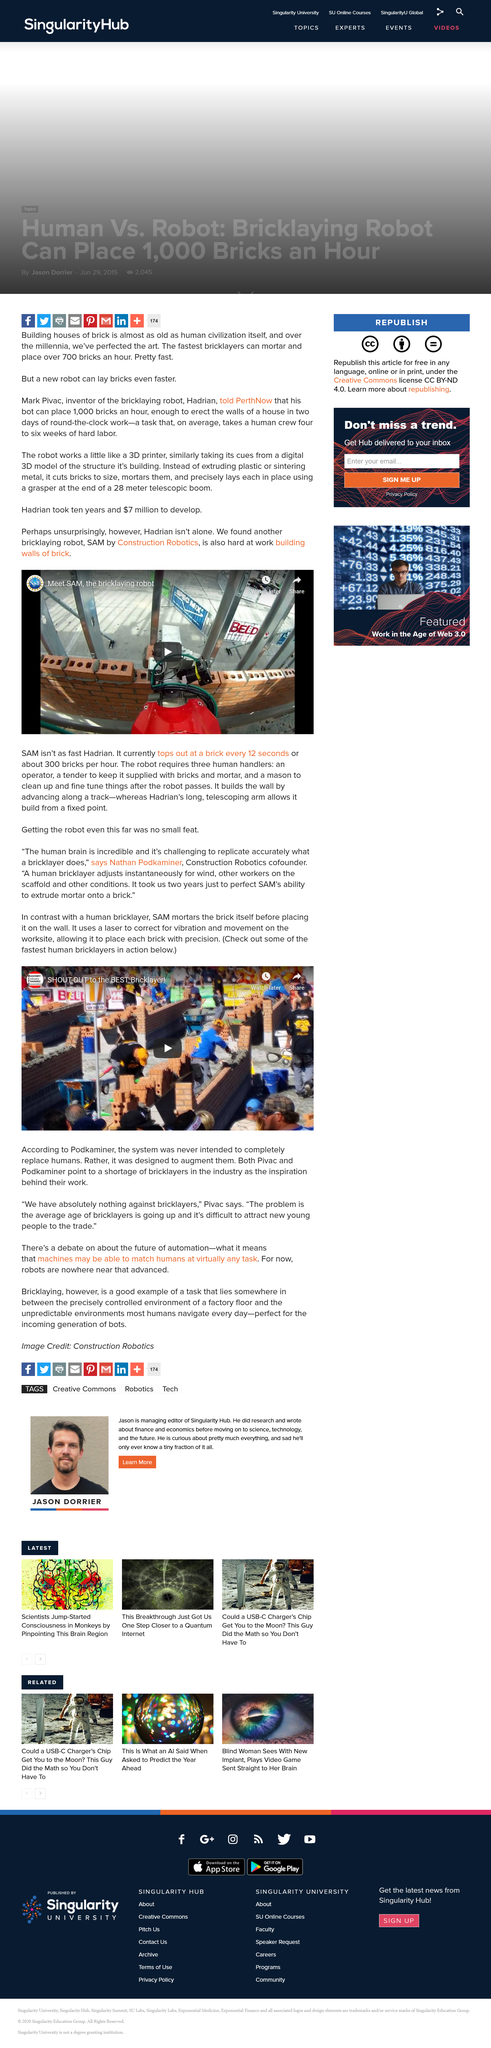Specify some key components in this picture. It took two years for SAM to perfect its ability to extrude mortar onto a brick. According to Podkaminer, the system was not designed to fully replace humans. ShaunPro, the YouTube channel owner, has uploaded a video titled "SHOUT-OUT to the BEST Bricklayer!". 